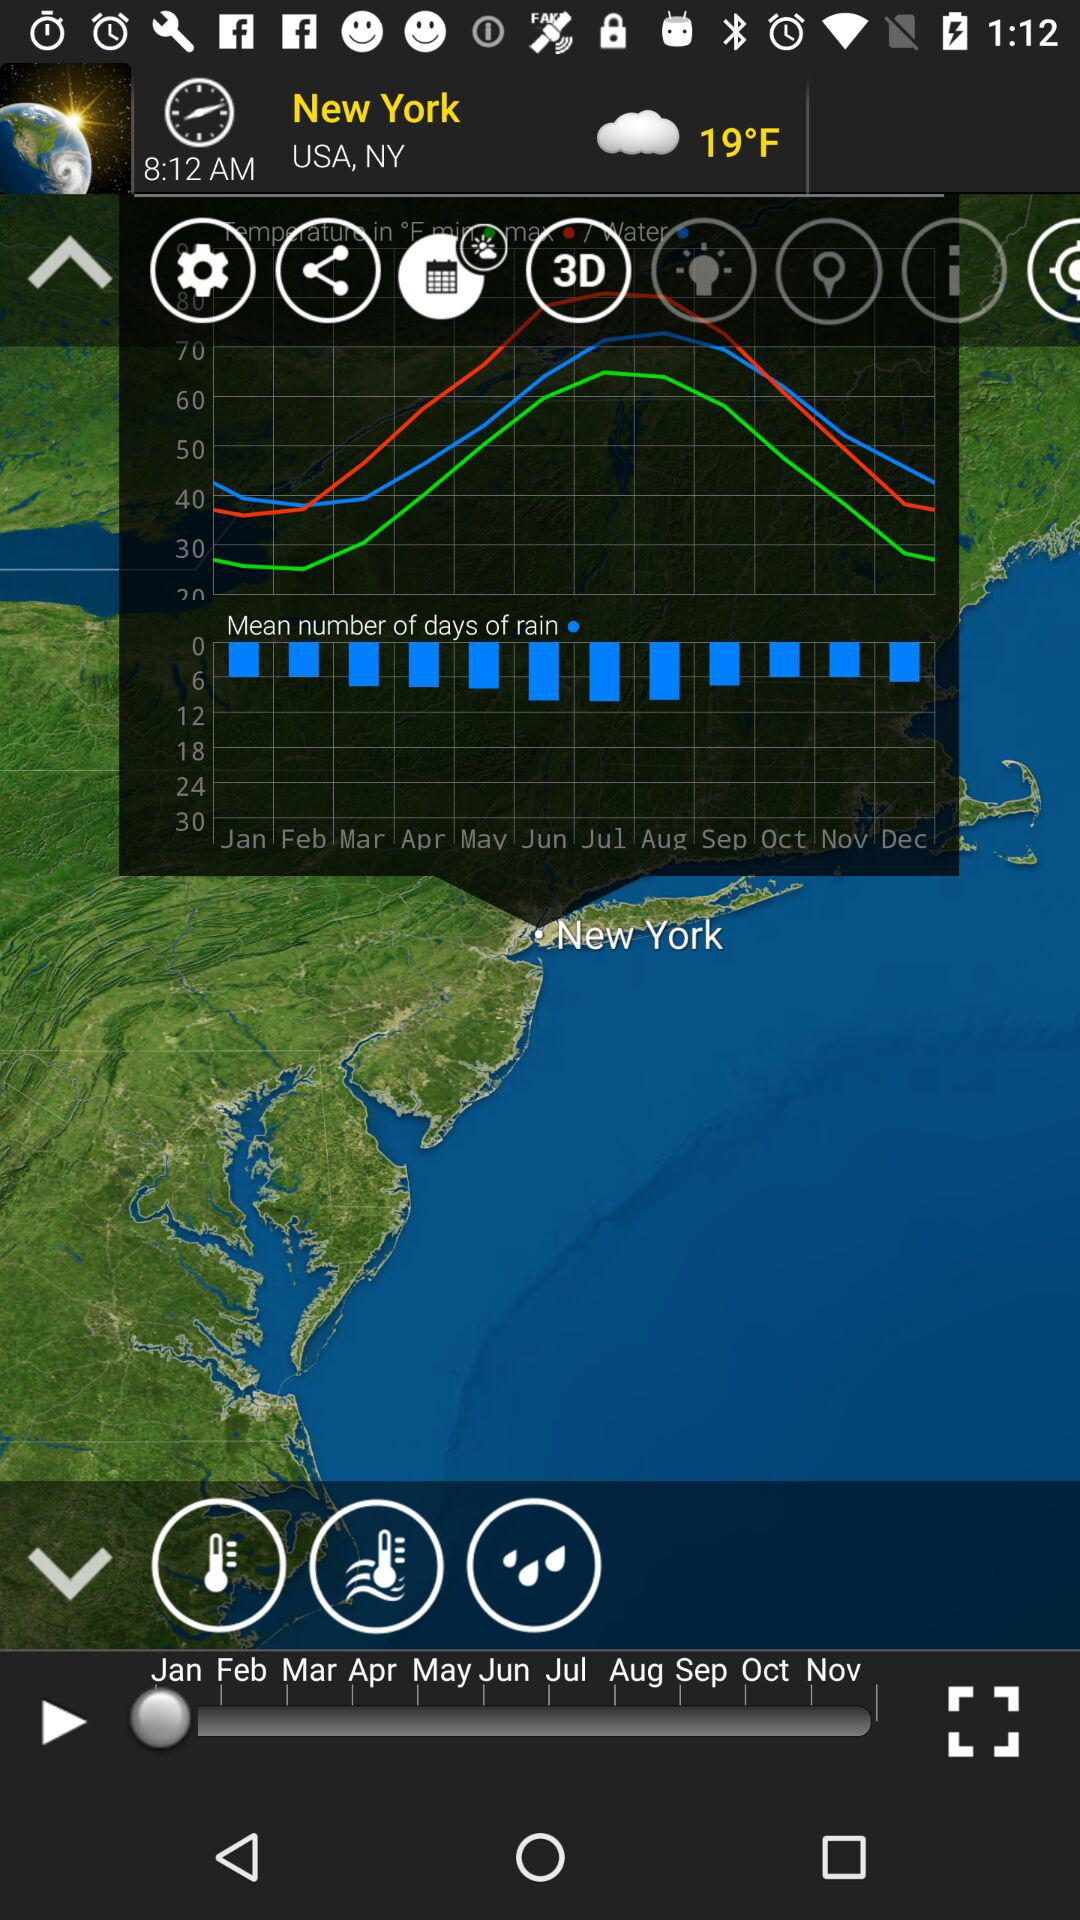What is the temperature? The temperature is 19°F. 